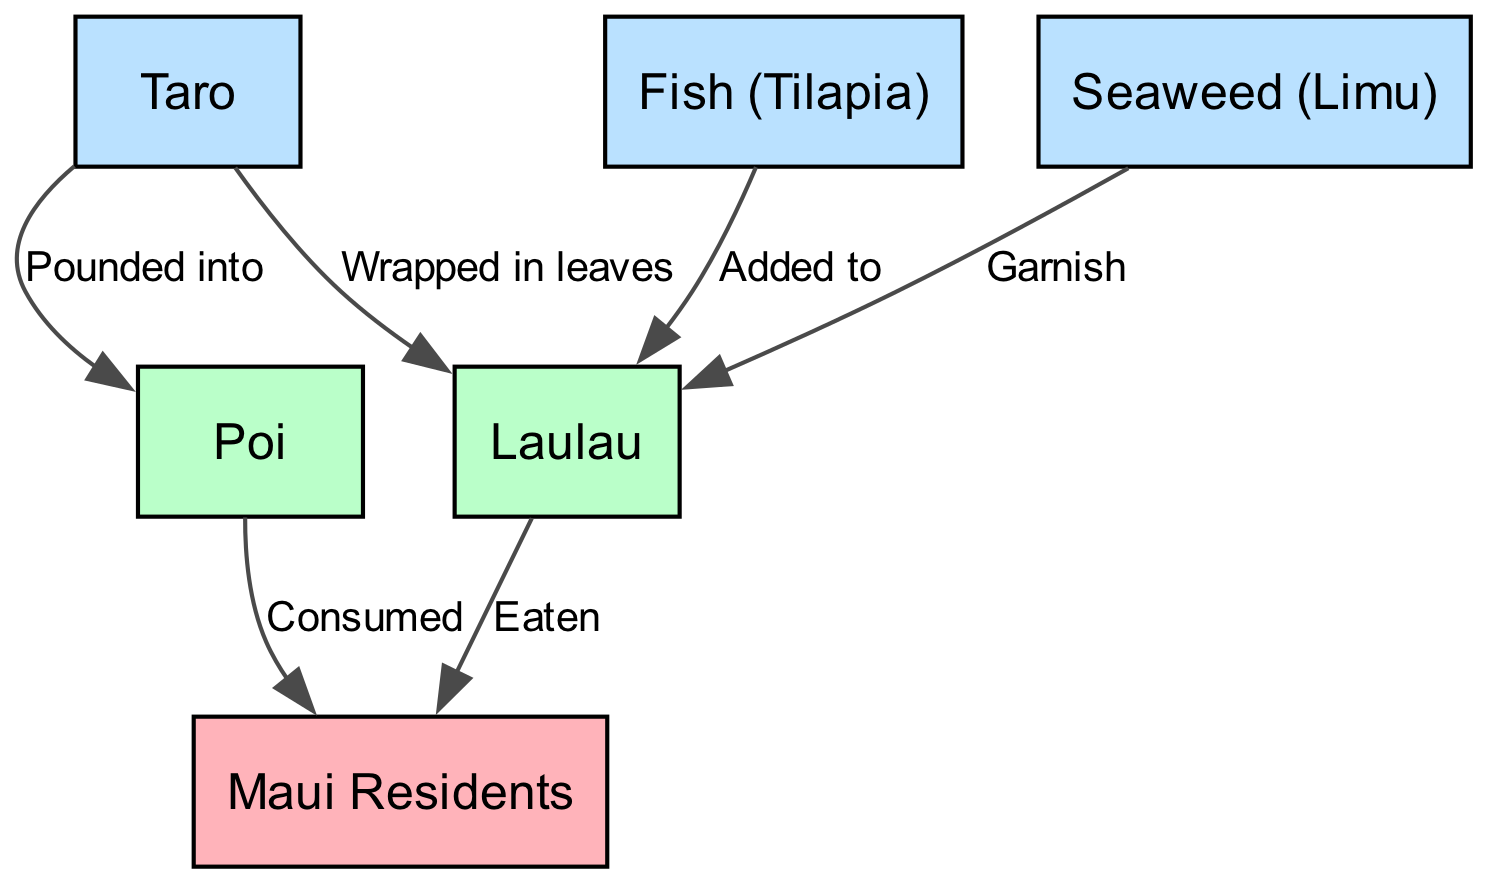What is the primary plant represented in the food chain? The diagram shows "Taro" as the primary plant at the beginning of the food chain. It is listed as the first node, indicating it is the original source in this agricultural food chain.
Answer: Taro How many nodes are there in the diagram? The diagram contains a total of 6 nodes, which represent different elements within the Hawaiian traditional agriculture food chain, including plants, animals, and humans.
Answer: 6 Which two food items are directly consumed by Maui Residents? According to the diagram, Maui Residents directly consume both "Poi" and "Laulau." The relationships show arrows pointing from these two items to the node representing Maui Residents, indicating consumption.
Answer: Poi, Laulau What is "Poi" made from? The diagram illustrates that "Poi" is made from "Taro," indicated by the edge labeled "Pounded into," connecting Taro to Poi. This means that the process involves pounding taro to create poi.
Answer: Taro What role does "Seaweed (Limu)" play in the food chain? The diagram shows that "Seaweed (Limu)" is used as a garnish for "Laulau," as indicated by the edge that connects the two, showing its relationship within the context of the food chain.
Answer: Garnish How is "Laulau" prepared in relation to "Taro"? "Laulau" is prepared by wrapping "Taro" in leaves, as indicated by the edge labeled "Wrapped in leaves" that connects Taro to Laulau, showcasing the method of preparation.
Answer: Wrapped in leaves Which animal is added to "Laulau"? The diagram specifies that "Fish (Tilapia)" is added to "Laulau," illustrated by the edge labeled "Added to," connecting these two nodes and indicating their relationship in the food chain.
Answer: Fish (Tilapia) In total, how many edges are present in the diagram? The diagram features 6 edges, which represent the relationships between the nodes, showing how each element interacts or connects in the food chain.
Answer: 6 What is the final point of consumption in the food chain? The final point of consumption in the diagram is "Maui Residents," signifying that they are the end consumers of the food chain, highlighted by arrows leading to them from both Poi and Laulau.
Answer: Maui Residents 